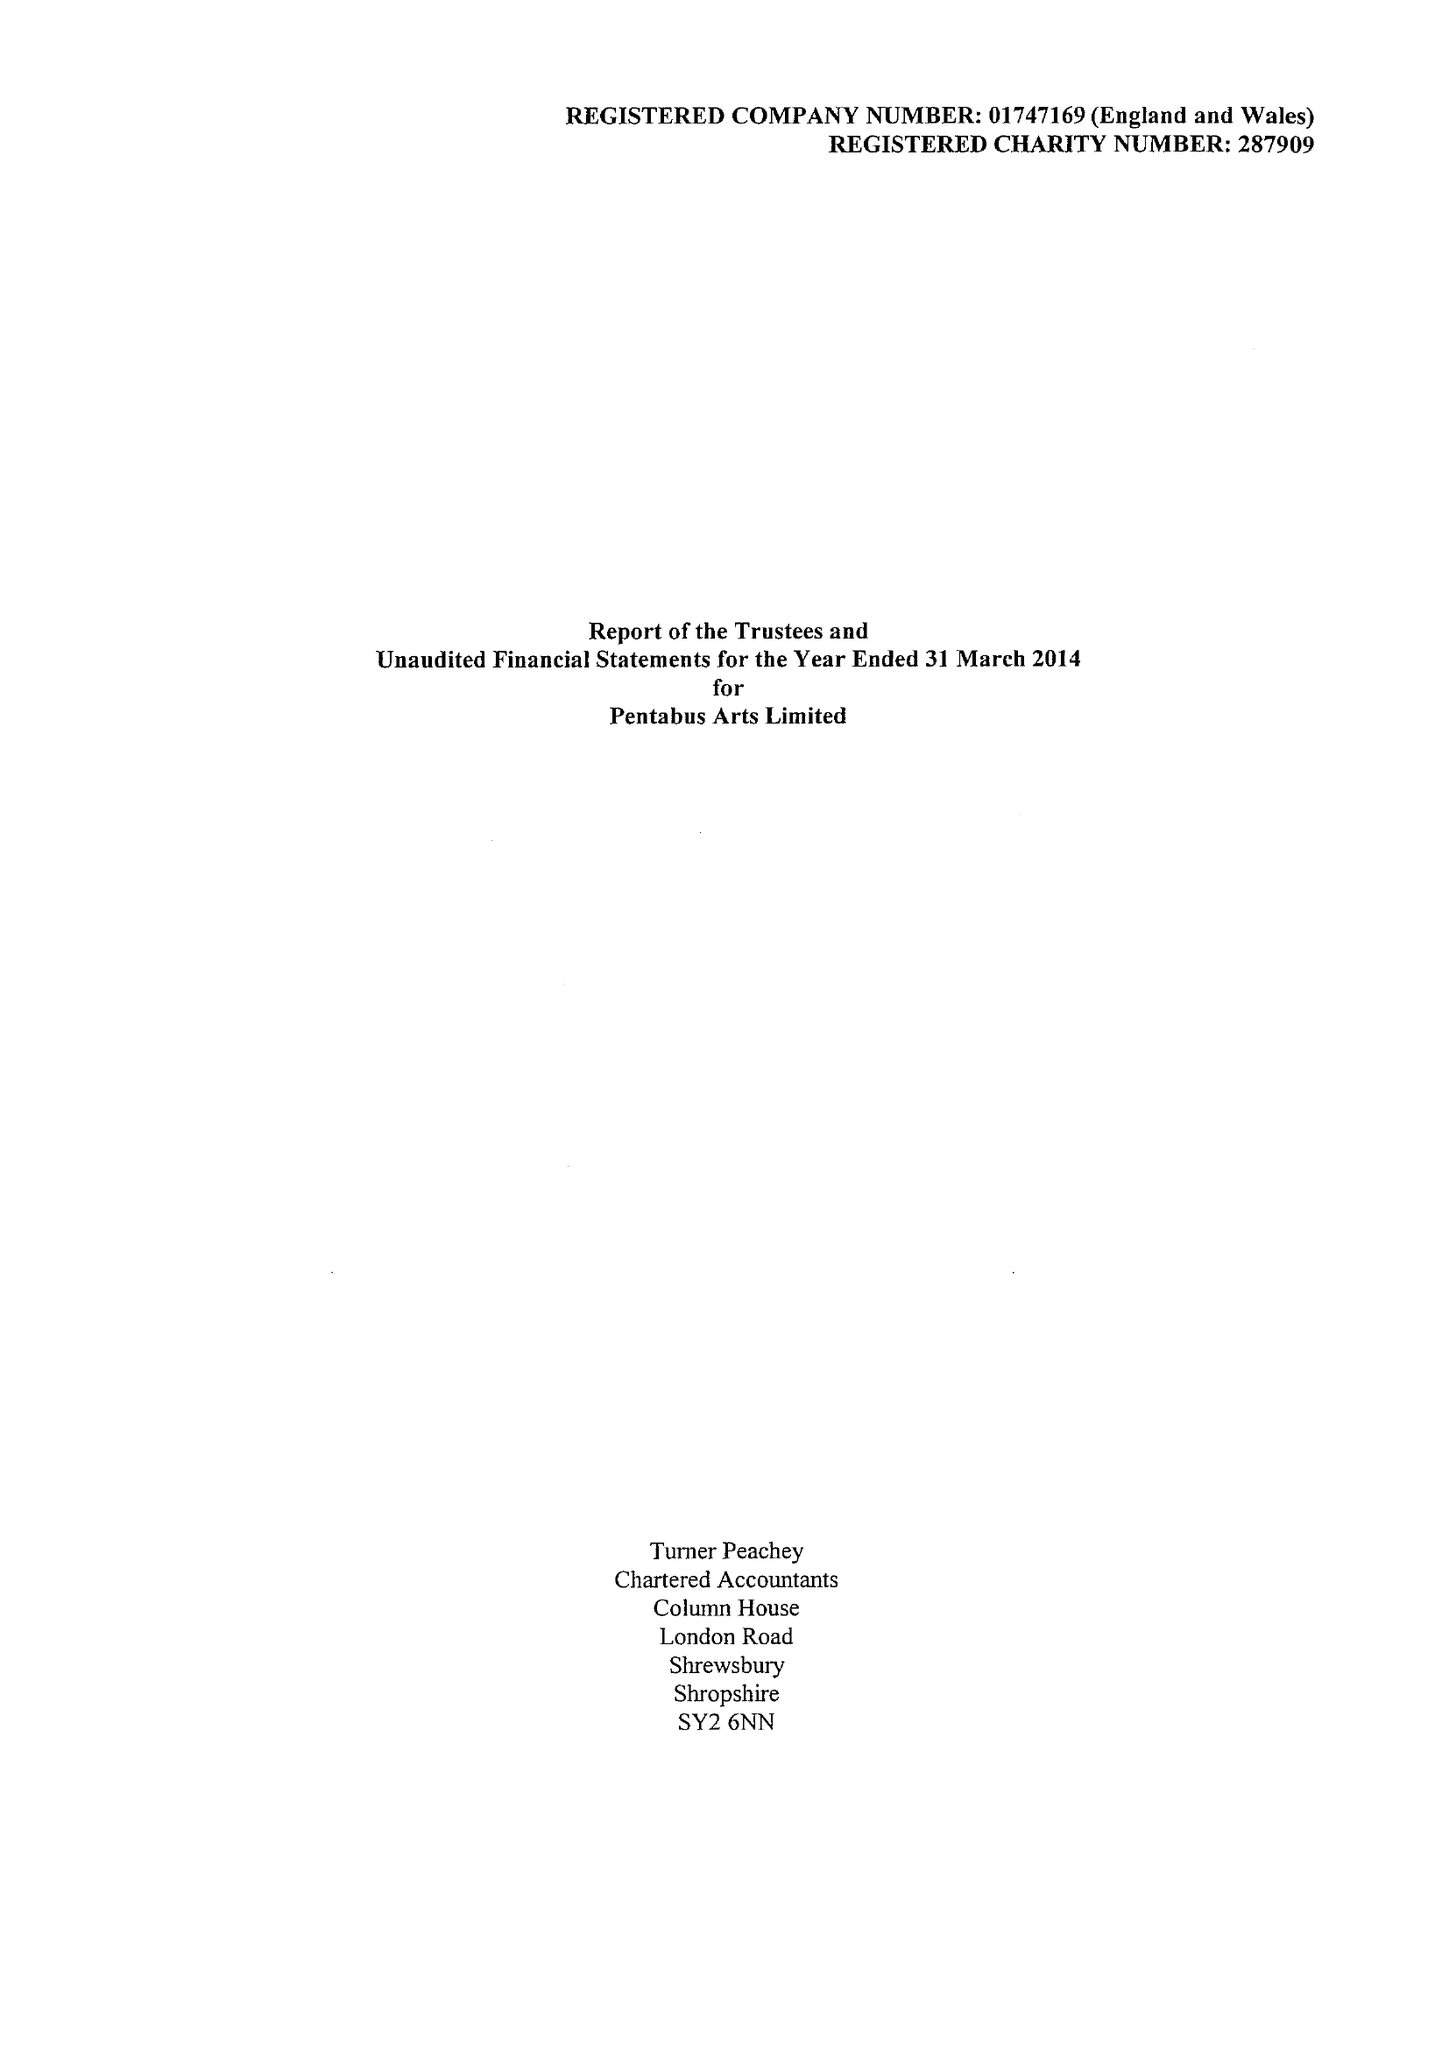What is the value for the report_date?
Answer the question using a single word or phrase. 2014-03-31 